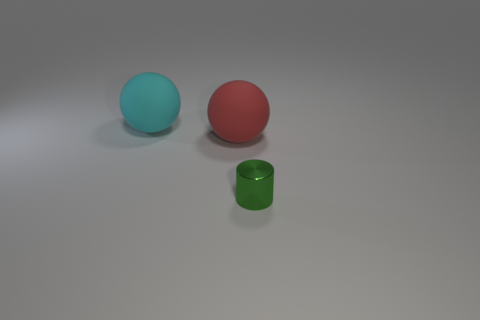Add 1 tiny cyan cylinders. How many objects exist? 4 Subtract all cylinders. How many objects are left? 2 Add 2 large gray cylinders. How many large gray cylinders exist? 2 Subtract 0 green balls. How many objects are left? 3 Subtract all red balls. Subtract all small cyan shiny objects. How many objects are left? 2 Add 3 small green metallic cylinders. How many small green metallic cylinders are left? 4 